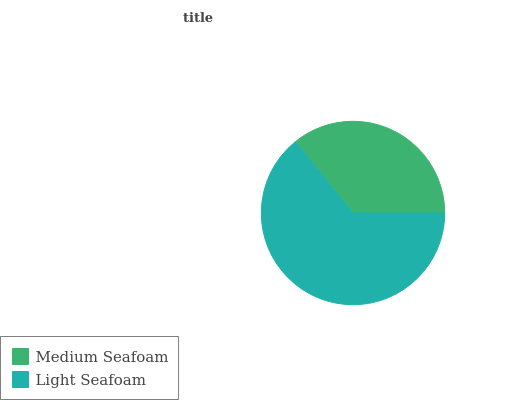Is Medium Seafoam the minimum?
Answer yes or no. Yes. Is Light Seafoam the maximum?
Answer yes or no. Yes. Is Light Seafoam the minimum?
Answer yes or no. No. Is Light Seafoam greater than Medium Seafoam?
Answer yes or no. Yes. Is Medium Seafoam less than Light Seafoam?
Answer yes or no. Yes. Is Medium Seafoam greater than Light Seafoam?
Answer yes or no. No. Is Light Seafoam less than Medium Seafoam?
Answer yes or no. No. Is Light Seafoam the high median?
Answer yes or no. Yes. Is Medium Seafoam the low median?
Answer yes or no. Yes. Is Medium Seafoam the high median?
Answer yes or no. No. Is Light Seafoam the low median?
Answer yes or no. No. 